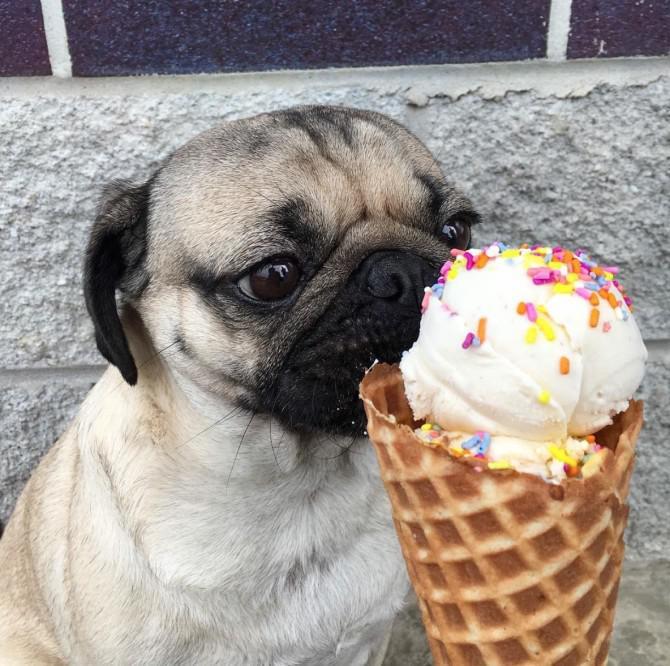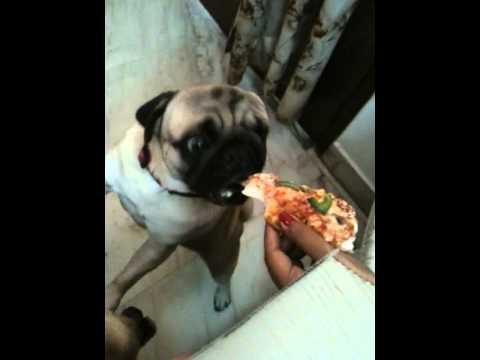The first image is the image on the left, the second image is the image on the right. Analyze the images presented: Is the assertion "A chubby beige pug is sitting in a container in one image, and the other image shows a pug with orange food in front of its mouth." valid? Answer yes or no. No. The first image is the image on the left, the second image is the image on the right. Analyze the images presented: Is the assertion "A dog is eating a plain cheese pizza in at least one of the images." valid? Answer yes or no. No. 